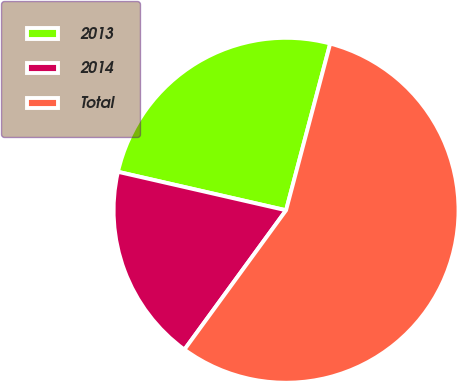<chart> <loc_0><loc_0><loc_500><loc_500><pie_chart><fcel>2013<fcel>2014<fcel>Total<nl><fcel>25.54%<fcel>18.55%<fcel>55.91%<nl></chart> 